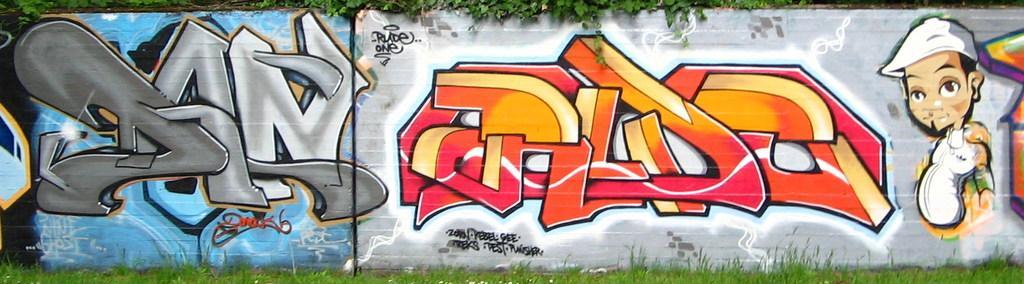Can you describe this image briefly? In this image I can see at the bottom there is the grass, in the middle there is the painting on the wall. At the top there are leaves in green color. 